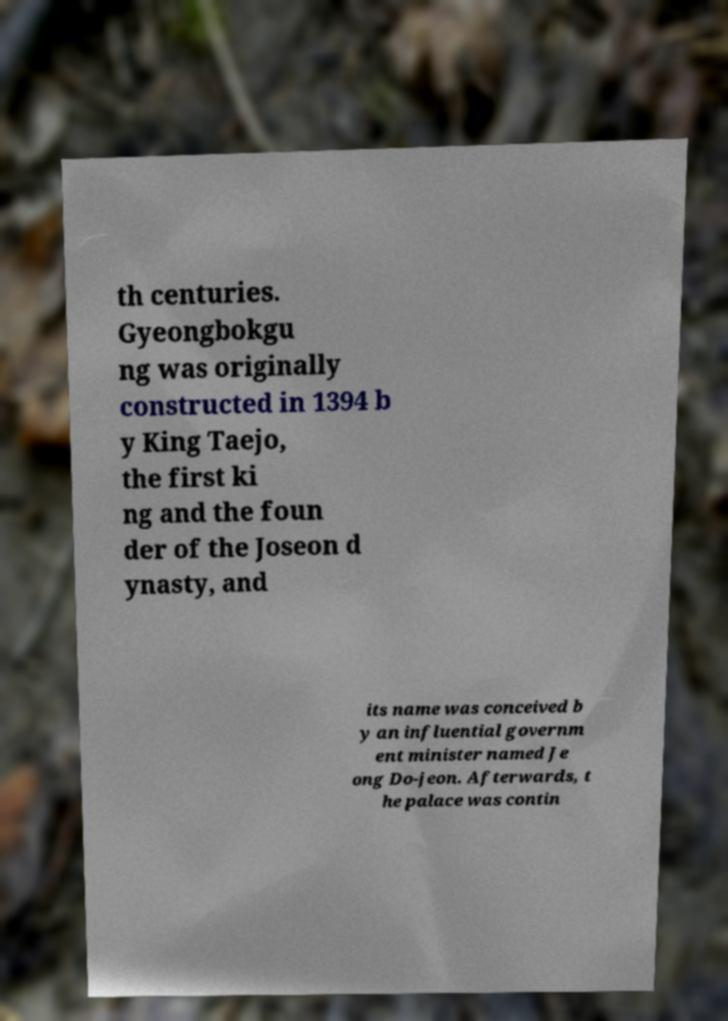Can you accurately transcribe the text from the provided image for me? th centuries. Gyeongbokgu ng was originally constructed in 1394 b y King Taejo, the first ki ng and the foun der of the Joseon d ynasty, and its name was conceived b y an influential governm ent minister named Je ong Do-jeon. Afterwards, t he palace was contin 